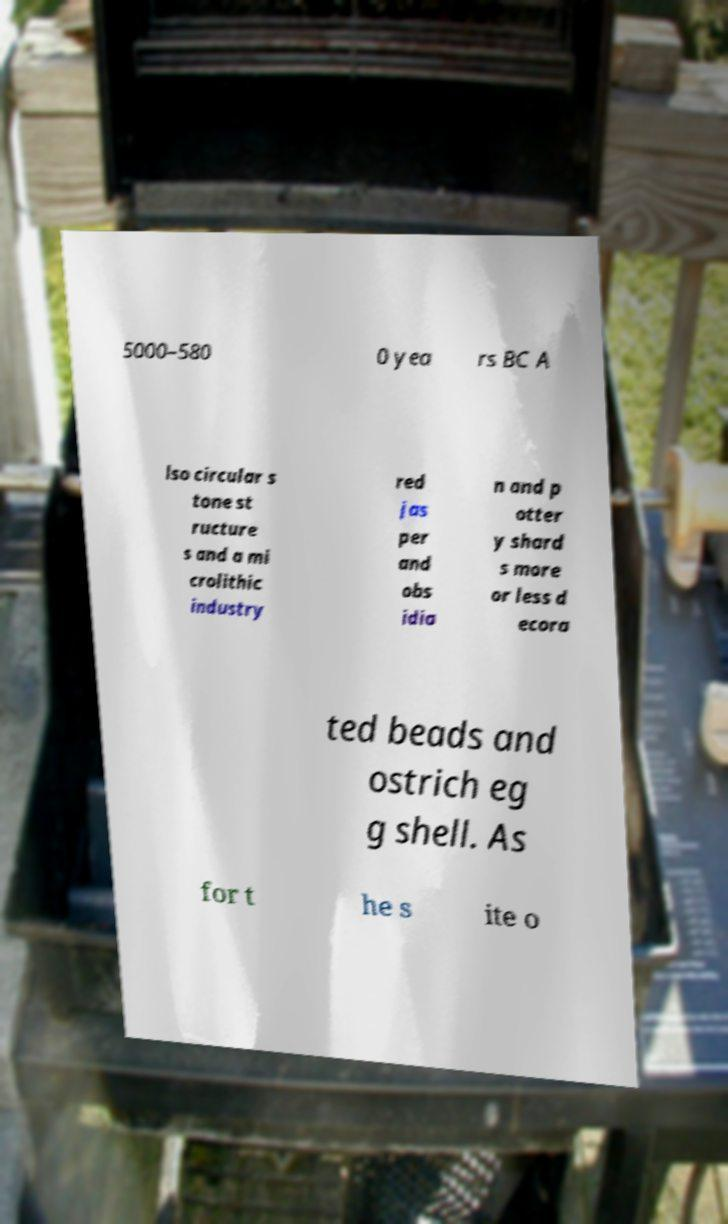There's text embedded in this image that I need extracted. Can you transcribe it verbatim? 5000–580 0 yea rs BC A lso circular s tone st ructure s and a mi crolithic industry red jas per and obs idia n and p otter y shard s more or less d ecora ted beads and ostrich eg g shell. As for t he s ite o 